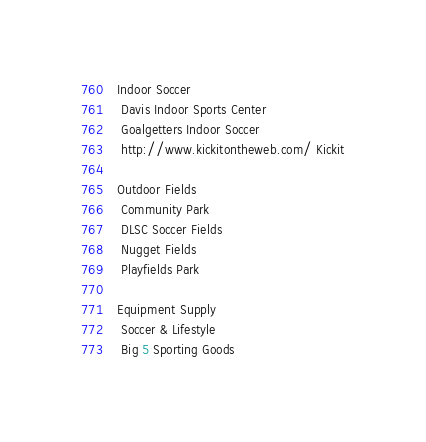Convert code to text. <code><loc_0><loc_0><loc_500><loc_500><_FORTRAN_> Indoor Soccer 
  Davis Indoor Sports Center
  Goalgetters Indoor Soccer
  http://www.kickitontheweb.com/ Kickit

 Outdoor Fields 
  Community Park
  DLSC Soccer Fields
  Nugget Fields
  Playfields Park

 Equipment Supply 
  Soccer & Lifestyle
  Big 5 Sporting Goods
</code> 